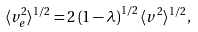Convert formula to latex. <formula><loc_0><loc_0><loc_500><loc_500>\langle v _ { e } ^ { 2 } \rangle ^ { 1 / 2 } = 2 \left ( 1 - \lambda \right ) ^ { 1 / 2 } \langle v ^ { 2 } \rangle ^ { 1 / 2 } ,</formula> 